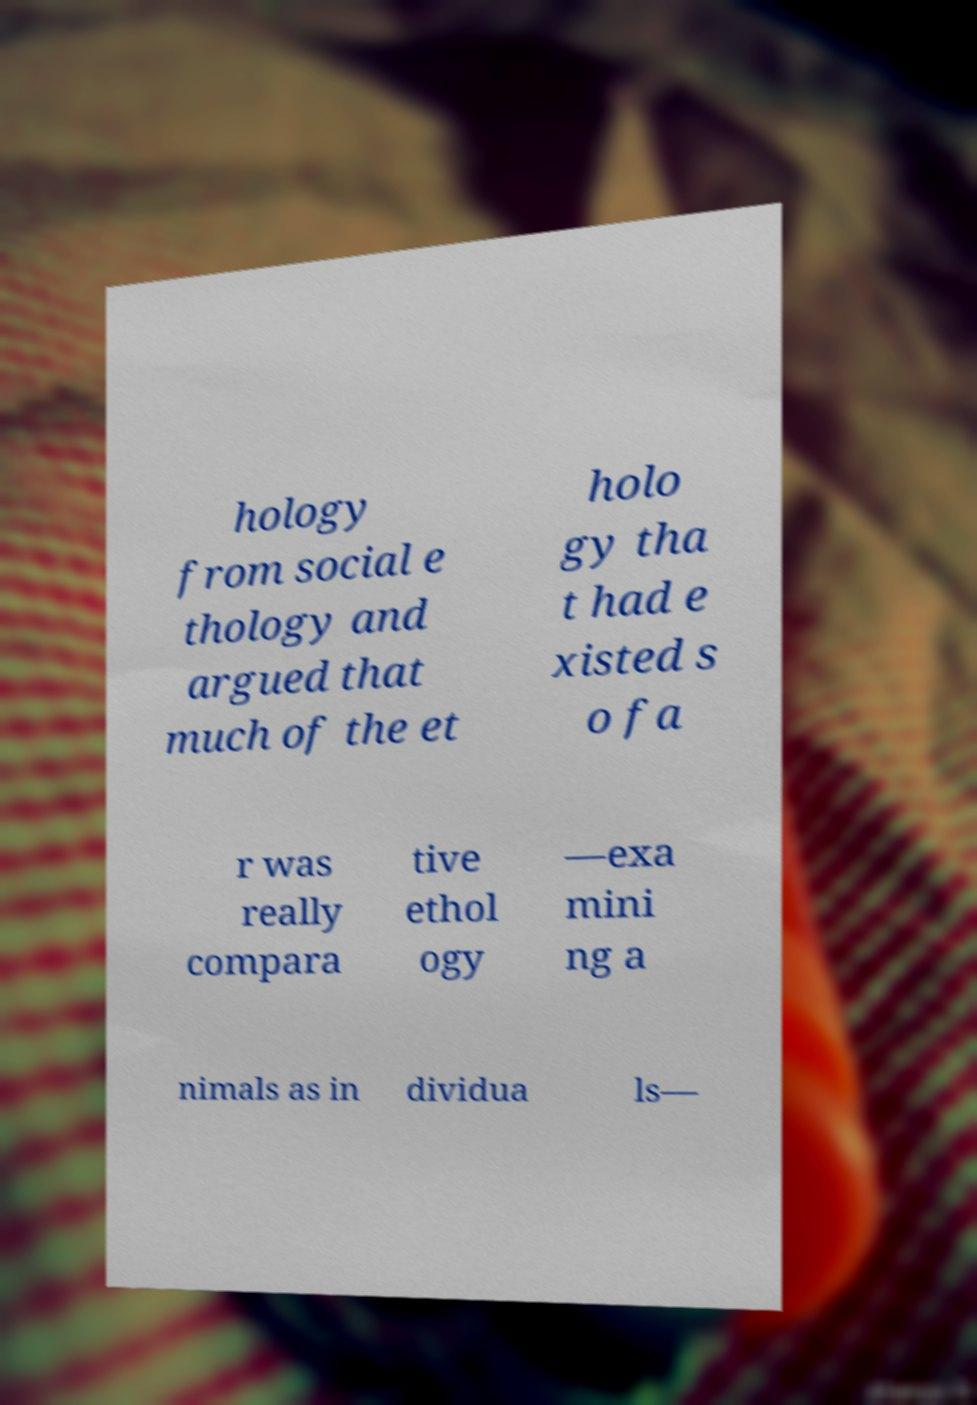Could you assist in decoding the text presented in this image and type it out clearly? hology from social e thology and argued that much of the et holo gy tha t had e xisted s o fa r was really compara tive ethol ogy —exa mini ng a nimals as in dividua ls— 